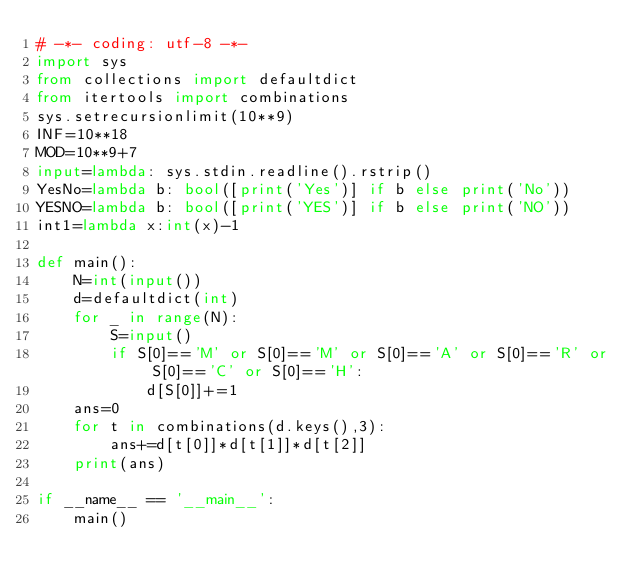Convert code to text. <code><loc_0><loc_0><loc_500><loc_500><_Python_># -*- coding: utf-8 -*-
import sys
from collections import defaultdict
from itertools import combinations
sys.setrecursionlimit(10**9)
INF=10**18
MOD=10**9+7
input=lambda: sys.stdin.readline().rstrip()
YesNo=lambda b: bool([print('Yes')] if b else print('No'))
YESNO=lambda b: bool([print('YES')] if b else print('NO'))
int1=lambda x:int(x)-1

def main():
    N=int(input())
    d=defaultdict(int)
    for _ in range(N):
        S=input()
        if S[0]=='M' or S[0]=='M' or S[0]=='A' or S[0]=='R' or S[0]=='C' or S[0]=='H':
            d[S[0]]+=1
    ans=0
    for t in combinations(d.keys(),3):
        ans+=d[t[0]]*d[t[1]]*d[t[2]]
    print(ans)

if __name__ == '__main__':
    main()
</code> 